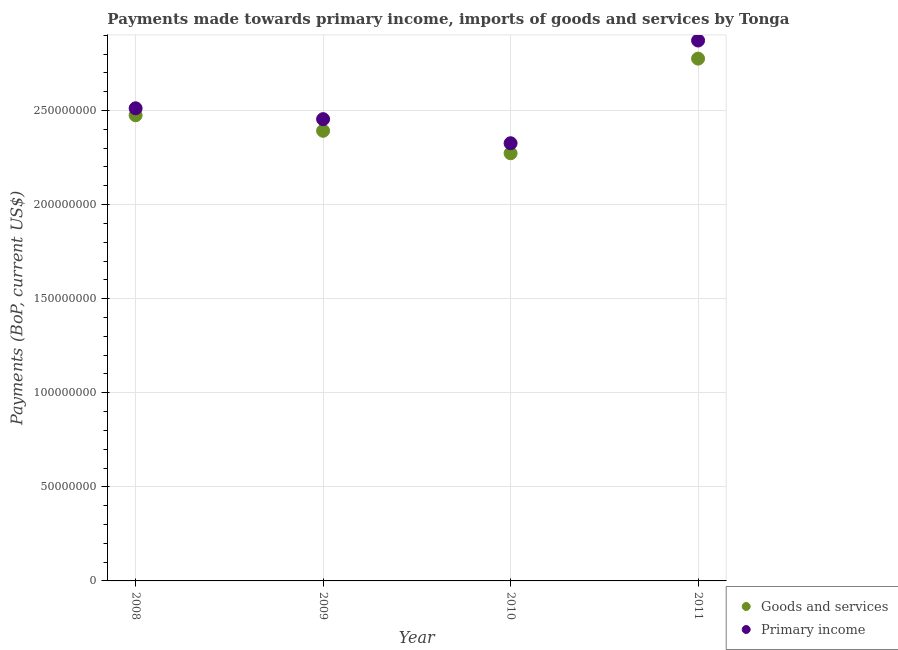What is the payments made towards goods and services in 2009?
Your answer should be very brief. 2.39e+08. Across all years, what is the maximum payments made towards primary income?
Offer a terse response. 2.87e+08. Across all years, what is the minimum payments made towards goods and services?
Give a very brief answer. 2.27e+08. What is the total payments made towards goods and services in the graph?
Give a very brief answer. 9.92e+08. What is the difference between the payments made towards goods and services in 2008 and that in 2010?
Keep it short and to the point. 2.02e+07. What is the difference between the payments made towards goods and services in 2011 and the payments made towards primary income in 2008?
Your answer should be compact. 2.64e+07. What is the average payments made towards goods and services per year?
Give a very brief answer. 2.48e+08. In the year 2011, what is the difference between the payments made towards goods and services and payments made towards primary income?
Provide a short and direct response. -9.63e+06. What is the ratio of the payments made towards goods and services in 2009 to that in 2010?
Your answer should be compact. 1.05. What is the difference between the highest and the second highest payments made towards goods and services?
Ensure brevity in your answer.  3.01e+07. What is the difference between the highest and the lowest payments made towards goods and services?
Ensure brevity in your answer.  5.03e+07. Is the sum of the payments made towards primary income in 2009 and 2010 greater than the maximum payments made towards goods and services across all years?
Your response must be concise. Yes. Is the payments made towards goods and services strictly greater than the payments made towards primary income over the years?
Give a very brief answer. No. How many dotlines are there?
Ensure brevity in your answer.  2. How many years are there in the graph?
Give a very brief answer. 4. What is the difference between two consecutive major ticks on the Y-axis?
Offer a terse response. 5.00e+07. Are the values on the major ticks of Y-axis written in scientific E-notation?
Keep it short and to the point. No. Does the graph contain grids?
Your answer should be compact. Yes. Where does the legend appear in the graph?
Your answer should be compact. Bottom right. How many legend labels are there?
Keep it short and to the point. 2. What is the title of the graph?
Your response must be concise. Payments made towards primary income, imports of goods and services by Tonga. Does "Lower secondary education" appear as one of the legend labels in the graph?
Your response must be concise. No. What is the label or title of the X-axis?
Provide a short and direct response. Year. What is the label or title of the Y-axis?
Make the answer very short. Payments (BoP, current US$). What is the Payments (BoP, current US$) in Goods and services in 2008?
Your answer should be very brief. 2.47e+08. What is the Payments (BoP, current US$) of Primary income in 2008?
Offer a very short reply. 2.51e+08. What is the Payments (BoP, current US$) of Goods and services in 2009?
Offer a very short reply. 2.39e+08. What is the Payments (BoP, current US$) in Primary income in 2009?
Offer a very short reply. 2.45e+08. What is the Payments (BoP, current US$) in Goods and services in 2010?
Give a very brief answer. 2.27e+08. What is the Payments (BoP, current US$) in Primary income in 2010?
Your answer should be compact. 2.33e+08. What is the Payments (BoP, current US$) of Goods and services in 2011?
Ensure brevity in your answer.  2.78e+08. What is the Payments (BoP, current US$) in Primary income in 2011?
Your answer should be very brief. 2.87e+08. Across all years, what is the maximum Payments (BoP, current US$) of Goods and services?
Offer a very short reply. 2.78e+08. Across all years, what is the maximum Payments (BoP, current US$) of Primary income?
Ensure brevity in your answer.  2.87e+08. Across all years, what is the minimum Payments (BoP, current US$) in Goods and services?
Ensure brevity in your answer.  2.27e+08. Across all years, what is the minimum Payments (BoP, current US$) of Primary income?
Offer a very short reply. 2.33e+08. What is the total Payments (BoP, current US$) of Goods and services in the graph?
Provide a short and direct response. 9.92e+08. What is the total Payments (BoP, current US$) in Primary income in the graph?
Your answer should be very brief. 1.02e+09. What is the difference between the Payments (BoP, current US$) of Goods and services in 2008 and that in 2009?
Offer a terse response. 8.26e+06. What is the difference between the Payments (BoP, current US$) in Primary income in 2008 and that in 2009?
Provide a succinct answer. 5.78e+06. What is the difference between the Payments (BoP, current US$) in Goods and services in 2008 and that in 2010?
Your answer should be compact. 2.02e+07. What is the difference between the Payments (BoP, current US$) of Primary income in 2008 and that in 2010?
Your answer should be compact. 1.86e+07. What is the difference between the Payments (BoP, current US$) of Goods and services in 2008 and that in 2011?
Give a very brief answer. -3.01e+07. What is the difference between the Payments (BoP, current US$) of Primary income in 2008 and that in 2011?
Provide a short and direct response. -3.60e+07. What is the difference between the Payments (BoP, current US$) in Goods and services in 2009 and that in 2010?
Provide a succinct answer. 1.19e+07. What is the difference between the Payments (BoP, current US$) of Primary income in 2009 and that in 2010?
Ensure brevity in your answer.  1.28e+07. What is the difference between the Payments (BoP, current US$) in Goods and services in 2009 and that in 2011?
Keep it short and to the point. -3.84e+07. What is the difference between the Payments (BoP, current US$) of Primary income in 2009 and that in 2011?
Offer a terse response. -4.18e+07. What is the difference between the Payments (BoP, current US$) in Goods and services in 2010 and that in 2011?
Keep it short and to the point. -5.03e+07. What is the difference between the Payments (BoP, current US$) in Primary income in 2010 and that in 2011?
Your response must be concise. -5.46e+07. What is the difference between the Payments (BoP, current US$) in Goods and services in 2008 and the Payments (BoP, current US$) in Primary income in 2009?
Make the answer very short. 2.07e+06. What is the difference between the Payments (BoP, current US$) in Goods and services in 2008 and the Payments (BoP, current US$) in Primary income in 2010?
Offer a terse response. 1.49e+07. What is the difference between the Payments (BoP, current US$) in Goods and services in 2008 and the Payments (BoP, current US$) in Primary income in 2011?
Make the answer very short. -3.97e+07. What is the difference between the Payments (BoP, current US$) in Goods and services in 2009 and the Payments (BoP, current US$) in Primary income in 2010?
Ensure brevity in your answer.  6.61e+06. What is the difference between the Payments (BoP, current US$) of Goods and services in 2009 and the Payments (BoP, current US$) of Primary income in 2011?
Offer a terse response. -4.80e+07. What is the difference between the Payments (BoP, current US$) in Goods and services in 2010 and the Payments (BoP, current US$) in Primary income in 2011?
Provide a succinct answer. -5.99e+07. What is the average Payments (BoP, current US$) of Goods and services per year?
Ensure brevity in your answer.  2.48e+08. What is the average Payments (BoP, current US$) of Primary income per year?
Provide a short and direct response. 2.54e+08. In the year 2008, what is the difference between the Payments (BoP, current US$) in Goods and services and Payments (BoP, current US$) in Primary income?
Provide a short and direct response. -3.70e+06. In the year 2009, what is the difference between the Payments (BoP, current US$) in Goods and services and Payments (BoP, current US$) in Primary income?
Give a very brief answer. -6.19e+06. In the year 2010, what is the difference between the Payments (BoP, current US$) in Goods and services and Payments (BoP, current US$) in Primary income?
Give a very brief answer. -5.32e+06. In the year 2011, what is the difference between the Payments (BoP, current US$) of Goods and services and Payments (BoP, current US$) of Primary income?
Your answer should be compact. -9.63e+06. What is the ratio of the Payments (BoP, current US$) of Goods and services in 2008 to that in 2009?
Keep it short and to the point. 1.03. What is the ratio of the Payments (BoP, current US$) in Primary income in 2008 to that in 2009?
Your answer should be very brief. 1.02. What is the ratio of the Payments (BoP, current US$) of Goods and services in 2008 to that in 2010?
Your answer should be very brief. 1.09. What is the ratio of the Payments (BoP, current US$) in Primary income in 2008 to that in 2010?
Offer a very short reply. 1.08. What is the ratio of the Payments (BoP, current US$) of Goods and services in 2008 to that in 2011?
Keep it short and to the point. 0.89. What is the ratio of the Payments (BoP, current US$) of Primary income in 2008 to that in 2011?
Your response must be concise. 0.87. What is the ratio of the Payments (BoP, current US$) in Goods and services in 2009 to that in 2010?
Ensure brevity in your answer.  1.05. What is the ratio of the Payments (BoP, current US$) of Primary income in 2009 to that in 2010?
Your response must be concise. 1.05. What is the ratio of the Payments (BoP, current US$) of Goods and services in 2009 to that in 2011?
Offer a very short reply. 0.86. What is the ratio of the Payments (BoP, current US$) of Primary income in 2009 to that in 2011?
Make the answer very short. 0.85. What is the ratio of the Payments (BoP, current US$) in Goods and services in 2010 to that in 2011?
Provide a succinct answer. 0.82. What is the ratio of the Payments (BoP, current US$) in Primary income in 2010 to that in 2011?
Provide a succinct answer. 0.81. What is the difference between the highest and the second highest Payments (BoP, current US$) of Goods and services?
Provide a succinct answer. 3.01e+07. What is the difference between the highest and the second highest Payments (BoP, current US$) in Primary income?
Offer a very short reply. 3.60e+07. What is the difference between the highest and the lowest Payments (BoP, current US$) in Goods and services?
Offer a very short reply. 5.03e+07. What is the difference between the highest and the lowest Payments (BoP, current US$) of Primary income?
Give a very brief answer. 5.46e+07. 